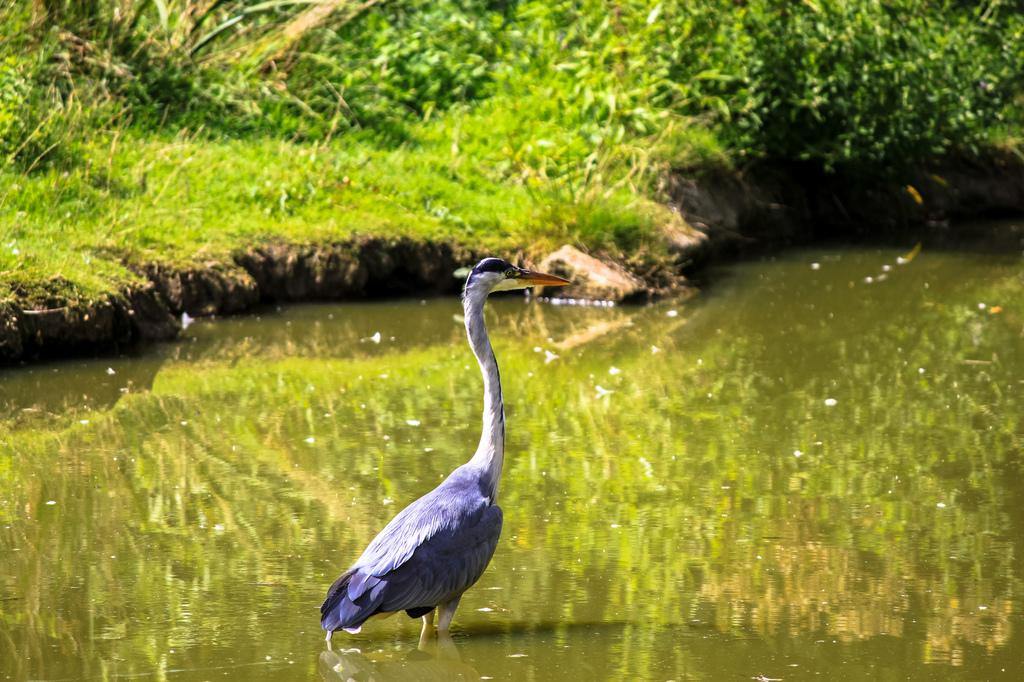What type of animal is in the image? There is a bird in the image. What colors can be seen on the bird? The bird has white, purple, and black colors. What is visible in the image besides the bird? There is water visible in the image. What type of vegetation is in the background of the image? There is green grass in the background of the image. How many frogs are jumping in the water in the image? There are no frogs present in the image; it features a bird with water in the background. What type of bubble is floating near the bird in the image? There is no bubble present in the image; it only features a bird and water. 